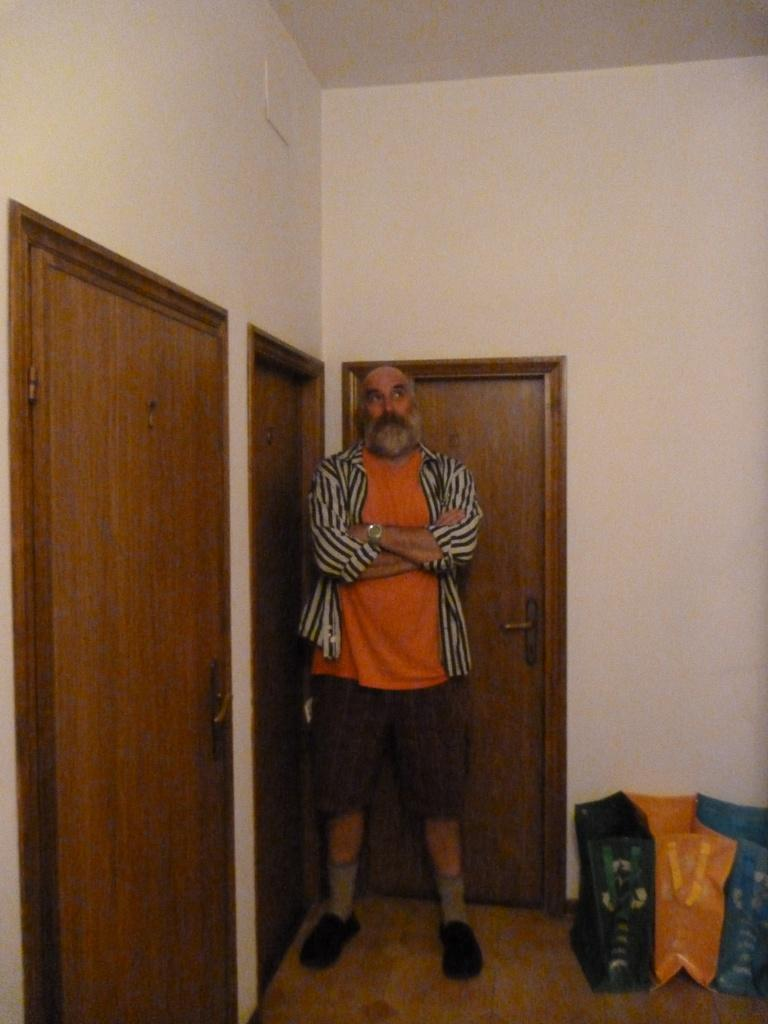What is the main subject in the image? There is a man standing in the image. What can be seen on the floor in the image? Bags are present on the floor. What architectural features are visible in the image? There are doors visible in the image. What type of structure is present in the image? There is a wall in the image. Can you see the man smiling in the image? The provided facts do not mention the man's facial expression, so it cannot be determined if he is smiling or not. 